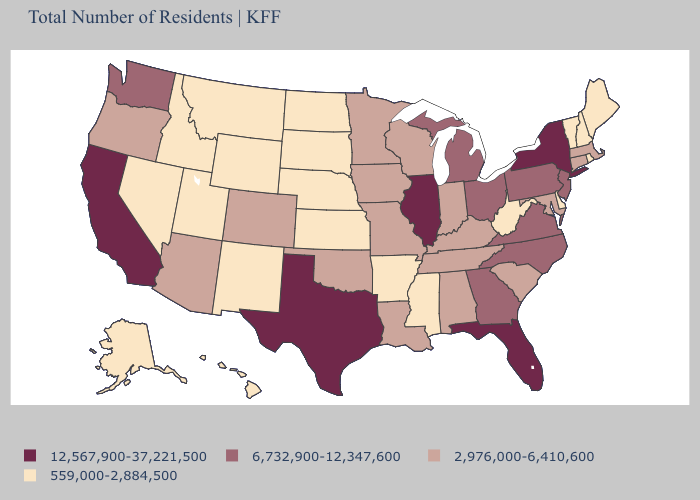Which states have the highest value in the USA?
Answer briefly. California, Florida, Illinois, New York, Texas. Does Georgia have the lowest value in the South?
Write a very short answer. No. What is the lowest value in the USA?
Keep it brief. 559,000-2,884,500. What is the value of Vermont?
Keep it brief. 559,000-2,884,500. What is the value of South Carolina?
Be succinct. 2,976,000-6,410,600. Name the states that have a value in the range 12,567,900-37,221,500?
Quick response, please. California, Florida, Illinois, New York, Texas. Which states hav the highest value in the Northeast?
Keep it brief. New York. Name the states that have a value in the range 559,000-2,884,500?
Give a very brief answer. Alaska, Arkansas, Delaware, Hawaii, Idaho, Kansas, Maine, Mississippi, Montana, Nebraska, Nevada, New Hampshire, New Mexico, North Dakota, Rhode Island, South Dakota, Utah, Vermont, West Virginia, Wyoming. Among the states that border New York , which have the lowest value?
Write a very short answer. Vermont. What is the lowest value in states that border South Dakota?
Write a very short answer. 559,000-2,884,500. Name the states that have a value in the range 12,567,900-37,221,500?
Short answer required. California, Florida, Illinois, New York, Texas. What is the value of Arizona?
Give a very brief answer. 2,976,000-6,410,600. Does Georgia have a lower value than Washington?
Short answer required. No. What is the value of Arkansas?
Be succinct. 559,000-2,884,500. Among the states that border West Virginia , which have the highest value?
Keep it brief. Ohio, Pennsylvania, Virginia. 